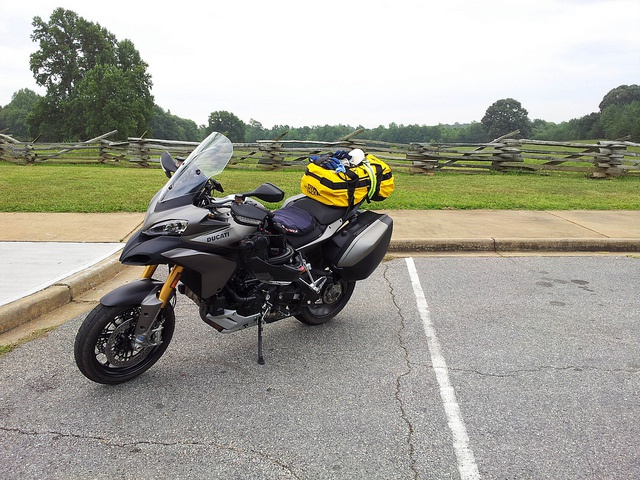Describe the objects in this image and their specific colors. I can see motorcycle in white, black, gray, darkgray, and lightgray tones and backpack in white, black, gold, and orange tones in this image. 